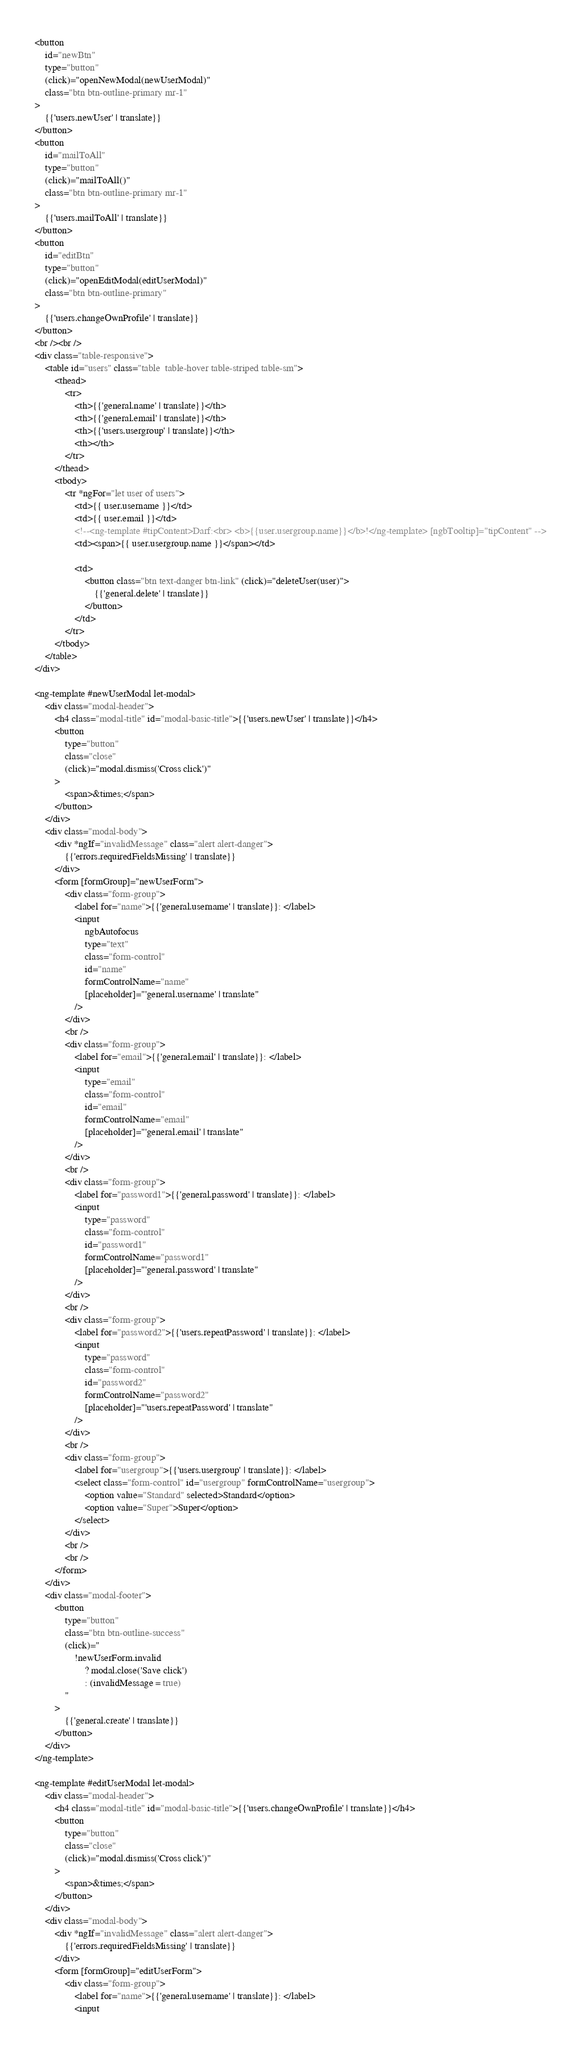<code> <loc_0><loc_0><loc_500><loc_500><_HTML_><button
    id="newBtn"
    type="button"
    (click)="openNewModal(newUserModal)"
    class="btn btn-outline-primary mr-1"
>
    {{'users.newUser' | translate}}
</button>
<button
    id="mailToAll"
    type="button"
    (click)="mailToAll()"
    class="btn btn-outline-primary mr-1"
>
    {{'users.mailToAll' | translate}}
</button>
<button
    id="editBtn"
    type="button"
    (click)="openEditModal(editUserModal)"
    class="btn btn-outline-primary"
>
    {{'users.changeOwnProfile' | translate}}
</button>
<br /><br />
<div class="table-responsive">
    <table id="users" class="table  table-hover table-striped table-sm">
        <thead>
            <tr>
                <th>{{'general.name' | translate}}</th>
                <th>{{'general.email' | translate}}</th>
                <th>{{'users.usergroup' | translate}}</th>
                <th></th>
            </tr>
        </thead>
        <tbody>
            <tr *ngFor="let user of users">
                <td>{{ user.username }}</td>
                <td>{{ user.email }}</td>
                <!--<ng-template #tipContent>Darf:<br> <b>{{user.usergroup.name}}</b>!</ng-template> [ngbTooltip]="tipContent" -->
                <td><span>{{ user.usergroup.name }}</span></td>

                <td>
                    <button class="btn text-danger btn-link" (click)="deleteUser(user)">
                        {{'general.delete' | translate}}
                    </button>
                </td>
            </tr>
        </tbody>
    </table>
</div>

<ng-template #newUserModal let-modal>
    <div class="modal-header">
        <h4 class="modal-title" id="modal-basic-title">{{'users.newUser' | translate}}</h4>
        <button
            type="button"
            class="close"
            (click)="modal.dismiss('Cross click')"
        >
            <span>&times;</span>
        </button>
    </div>
    <div class="modal-body">
        <div *ngIf="invalidMessage" class="alert alert-danger">
            {{'errors.requiredFieldsMissing' | translate}}
        </div>
        <form [formGroup]="newUserForm">
            <div class="form-group">
                <label for="name">{{'general.username' | translate}}: </label>
                <input
                    ngbAutofocus
                    type="text"
                    class="form-control"
                    id="name"
                    formControlName="name"
                    [placeholder]="'general.username' | translate"
                />
            </div>
            <br />
            <div class="form-group">
                <label for="email">{{'general.email' | translate}}: </label>
                <input
                    type="email"
                    class="form-control"
                    id="email"
                    formControlName="email"
                    [placeholder]="'general.email' | translate"
                />
            </div>
            <br />
            <div class="form-group">
                <label for="password1">{{'general.password' | translate}}: </label>
                <input
                    type="password"
                    class="form-control"
                    id="password1"
                    formControlName="password1"
                    [placeholder]="'general.password' | translate"
                />
            </div>
            <br />
            <div class="form-group">
                <label for="password2">{{'users.repeatPassword' | translate}}: </label>
                <input
                    type="password"
                    class="form-control"
                    id="password2"
                    formControlName="password2"
                    [placeholder]="'users.repeatPassword' | translate"
                />
            </div>
            <br />
            <div class="form-group">
                <label for="usergroup">{{'users.usergroup' | translate}}: </label>
                <select class="form-control" id="usergroup" formControlName="usergroup">
                    <option value="Standard" selected>Standard</option>
                    <option value="Super">Super</option>
                </select>
            </div>
            <br />
            <br />
        </form>
    </div>
    <div class="modal-footer">
        <button
            type="button"
            class="btn btn-outline-success"
            (click)="
                !newUserForm.invalid
                    ? modal.close('Save click')
                    : (invalidMessage = true)
            "
        >
            {{'general.create' | translate}}
        </button>
    </div>
</ng-template>

<ng-template #editUserModal let-modal>
    <div class="modal-header">
        <h4 class="modal-title" id="modal-basic-title">{{'users.changeOwnProfile' | translate}}</h4>
        <button
            type="button"
            class="close"
            (click)="modal.dismiss('Cross click')"
        >
            <span>&times;</span>
        </button>
    </div>
    <div class="modal-body">
        <div *ngIf="invalidMessage" class="alert alert-danger">
            {{'errors.requiredFieldsMissing' | translate}}
        </div>
        <form [formGroup]="editUserForm">
            <div class="form-group">
                <label for="name">{{'general.username' | translate}}: </label>
                <input</code> 